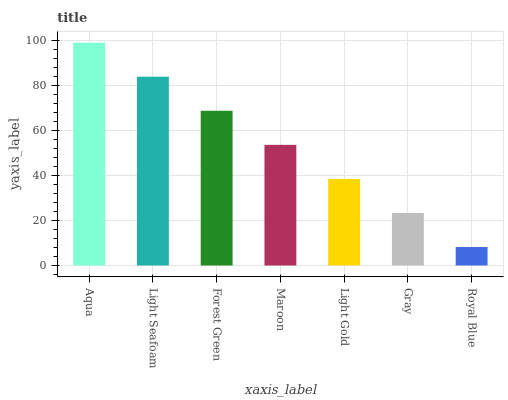Is Royal Blue the minimum?
Answer yes or no. Yes. Is Aqua the maximum?
Answer yes or no. Yes. Is Light Seafoam the minimum?
Answer yes or no. No. Is Light Seafoam the maximum?
Answer yes or no. No. Is Aqua greater than Light Seafoam?
Answer yes or no. Yes. Is Light Seafoam less than Aqua?
Answer yes or no. Yes. Is Light Seafoam greater than Aqua?
Answer yes or no. No. Is Aqua less than Light Seafoam?
Answer yes or no. No. Is Maroon the high median?
Answer yes or no. Yes. Is Maroon the low median?
Answer yes or no. Yes. Is Light Seafoam the high median?
Answer yes or no. No. Is Light Gold the low median?
Answer yes or no. No. 